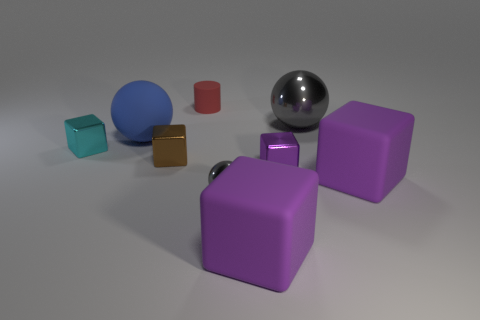How many purple blocks must be subtracted to get 1 purple blocks? 2 Subtract all green cylinders. How many purple cubes are left? 3 Subtract all large purple blocks. How many blocks are left? 3 Subtract 3 cubes. How many cubes are left? 2 Subtract all brown cubes. How many cubes are left? 4 Subtract all blue cubes. Subtract all green cylinders. How many cubes are left? 5 Subtract all cylinders. How many objects are left? 8 Subtract all small purple matte cubes. Subtract all large blue spheres. How many objects are left? 8 Add 5 purple shiny objects. How many purple shiny objects are left? 6 Add 7 small red rubber cylinders. How many small red rubber cylinders exist? 8 